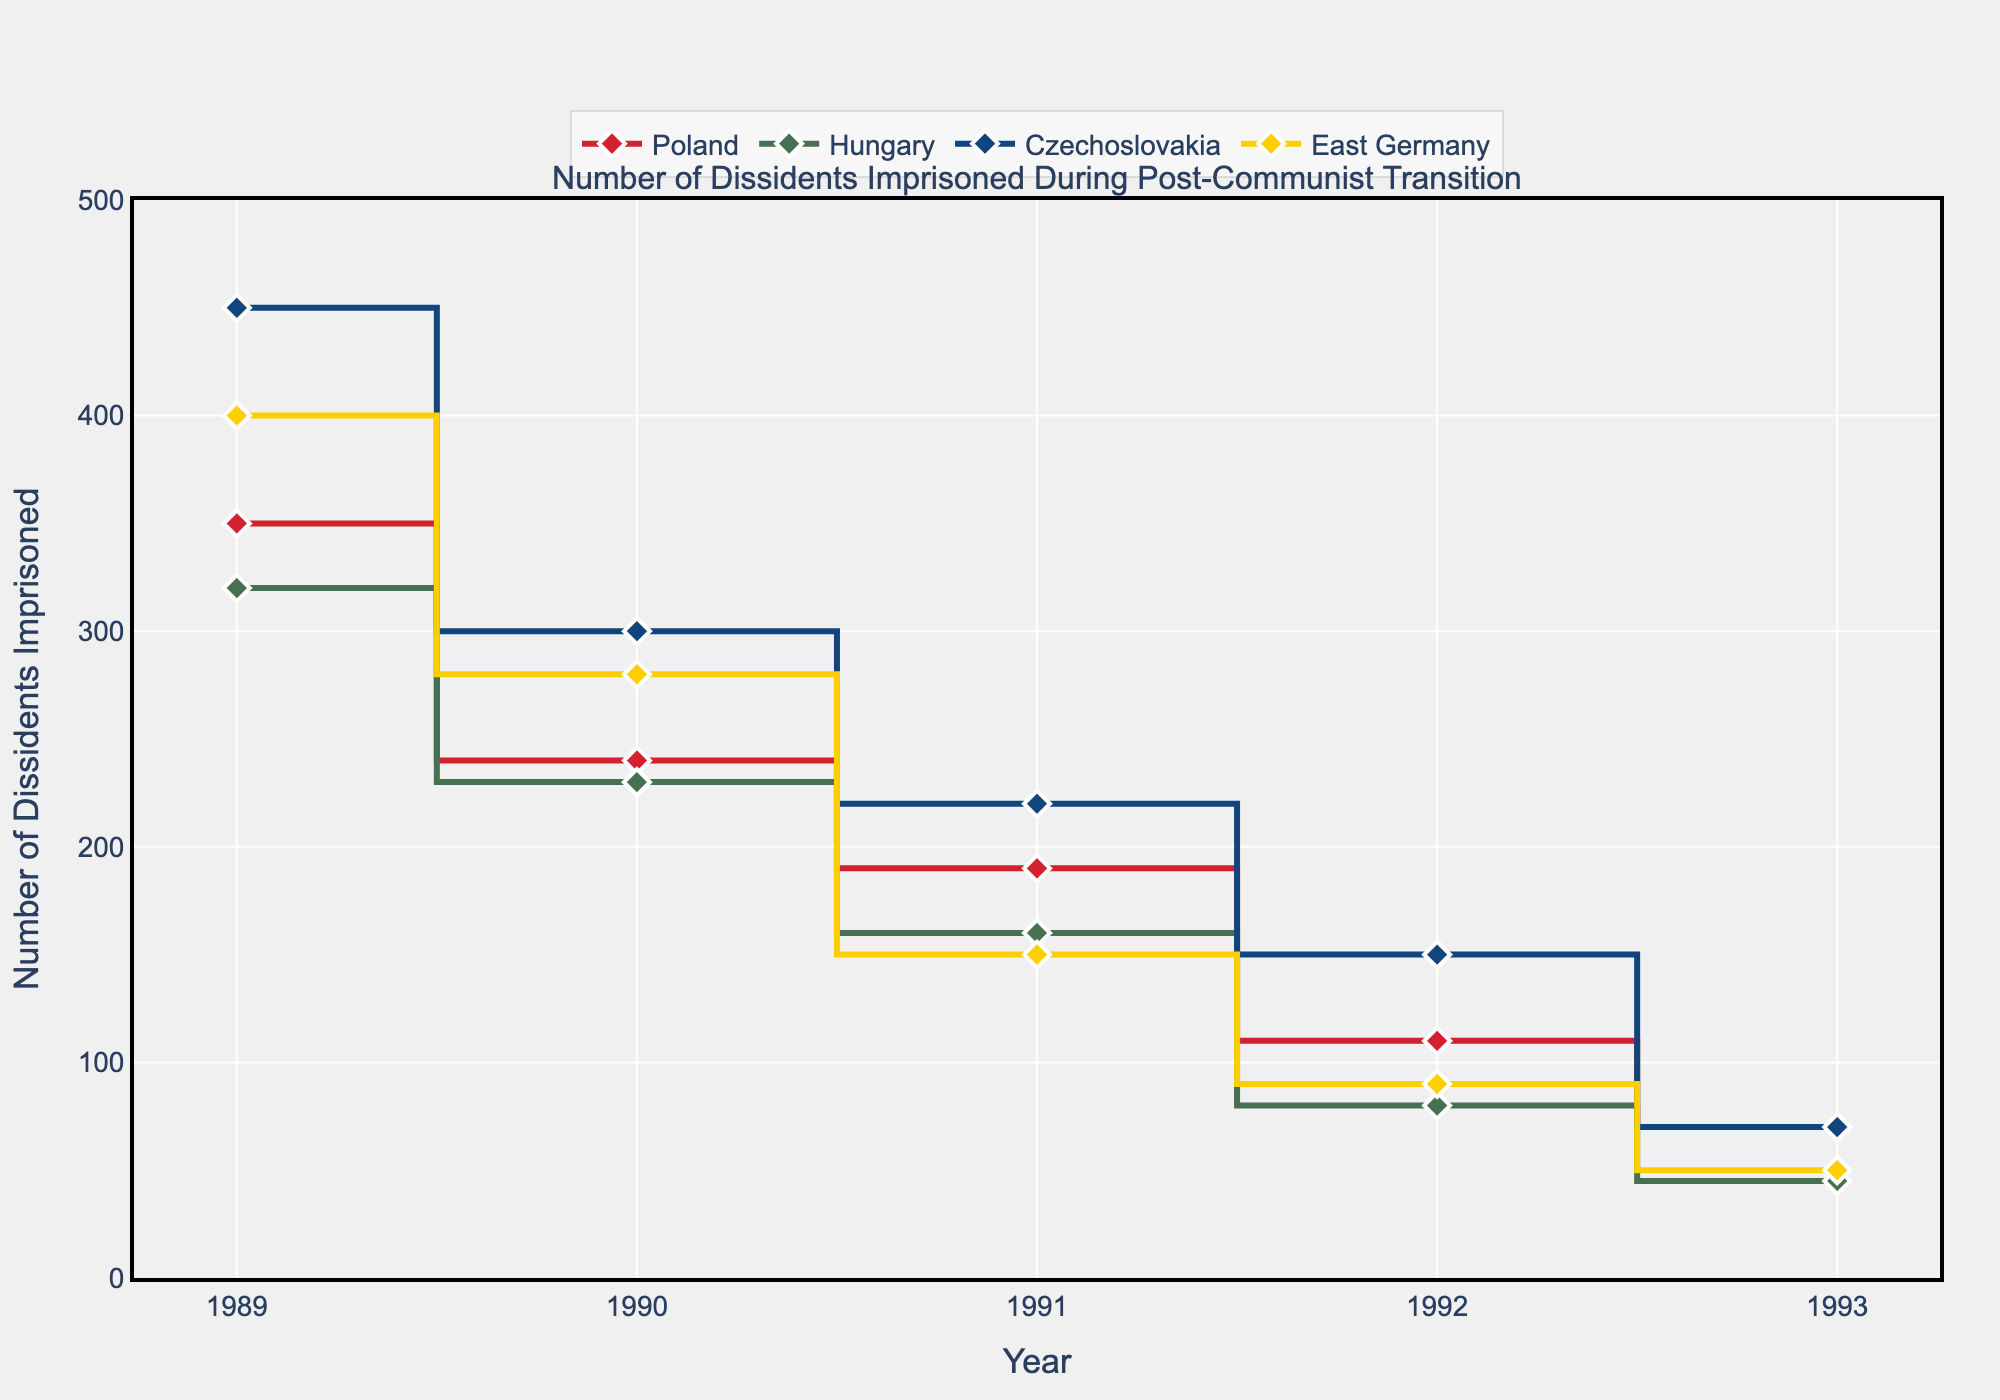How does the number of dissidents imprisoned in Poland change from 1989 to 1993? Looking at the data points for Poland, the number of dissidents imprisoned decreases each year: 350 in 1989, 240 in 1990, 190 in 1991, 110 in 1992, and 70 in 1993.
Answer: Decreases each year Which country had the highest number of dissidents imprisoned in 1990? In 1990, the data points show Poland with 240, Hungary with 230, Czechoslovakia with 300, and East Germany with 280. Czechoslovakia had the highest number.
Answer: Czechoslovakia What is the overall trend for East Germany from 1989 to 1993? For East Germany, the number of dissidents imprisoned decreases each year: 400 in 1989, 280 in 1990, 150 in 1991, 90 in 1992, and 50 in 1993.
Answer: Decreasing Between which consecutive years did Czechoslovakia see the largest decline in the number of dissidents imprisoned? Comparing the differences: 450 to 300 (150) from 1989 to 1990, 300 to 220 (80) from 1990 to 1991, 220 to 150 (70) from 1991 to 1992, and 150 to 70 (80) from 1992 to 1993. The largest decline is from 1989 to 1990.
Answer: 1989 to 1990 Which country had the smallest number of dissidents imprisoned in 1993, and what was the figure? In 1993, the figures are Poland with 70, Hungary with 45, Czechoslovakia with 70, and East Germany with 50. Hungary had the smallest number with 45.
Answer: Hungary, 45 What is the total number of dissidents imprisoned in 1991 across all four countries? Adding the numbers for 1991: Poland (190) + Hungary (160) + Czechoslovakia (220) + East Germany (150) equals 720.
Answer: 720 Between 1989 and 1993, which country had the greatest overall reduction in the number of dissidents imprisoned? Calculating the reduction for each country: Poland (350 to 70 = 280), Hungary (320 to 45 = 275), Czechoslovakia (450 to 70 = 380), East Germany (400 to 50 = 350). Czechoslovakia had the greatest reduction.
Answer: Czechoslovakia What is the common trend observed in all four countries during the transition period? All four countries show a consistent decrease in the number of dissidents imprisoned from 1989 to 1993.
Answer: Decreasing trend Is there any year where the number of dissidents imprisoned is equal for two countries? If so, which year and what countries? In 1993, both Poland and Czechoslovakia have 70 dissidents imprisoned.
Answer: 1993, Poland and Czechoslovakia 